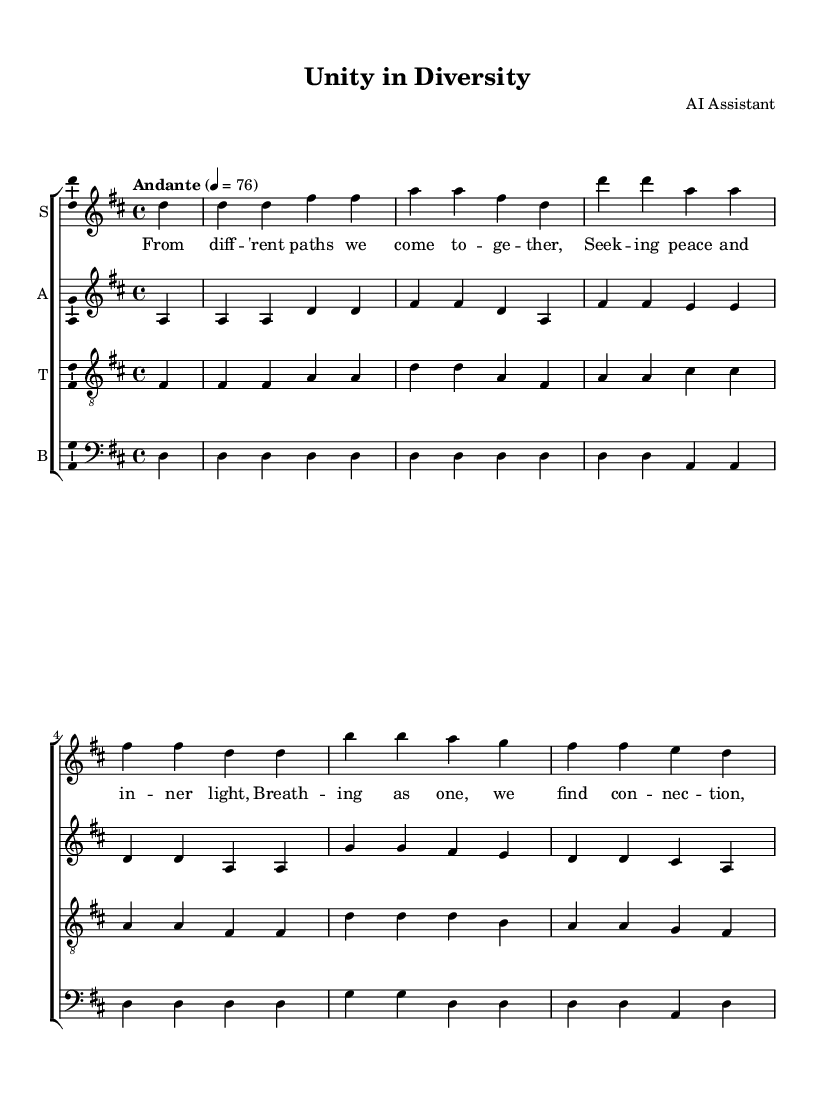What is the key signature of this music? The key signature is indicated at the beginning of the score, where we see two sharps, which corresponds to D major.
Answer: D major What is the time signature of this music? The time signature is shown at the beginning of the score as 4/4, meaning there are four beats in each measure and a quarter note receives one beat.
Answer: 4/4 What tempo marking is given in this music? The tempo marking "Andante" is located at the start of the score, indicating a moderate pace of music.
Answer: Andante How many vocal parts are included in this piece? The score displays four distinct staves, one for each vocal part: soprano, alto, tenor, and bass. This indicates there are four vocal parts.
Answer: Four What is the primary theme expressed in the lyrics? The lyrics emphasize unity and connection across different paths and beliefs, promoting a sense of harmony and mindfulness.
Answer: Unity and connection Which section of the music contains the lyrics "In harmony we stand united"? The lyrics "In harmony we stand united" are found in the chorus section, which follows the verse in the structure of the piece.
Answer: Chorus What role does this choral piece serve within interfaith contexts? This choral piece serves to promote harmony and mindfulness across different belief systems, fostering a spirit of unity amid diversity.
Answer: Promote harmony across belief systems 